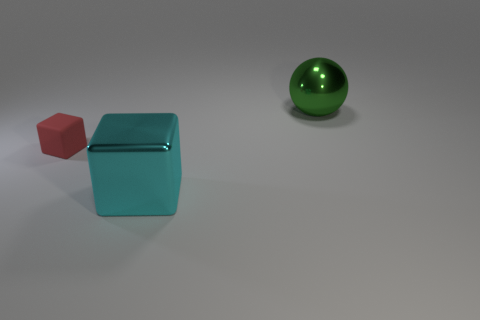Add 3 big spheres. How many objects exist? 6 Subtract 2 cubes. How many cubes are left? 0 Subtract all tiny balls. Subtract all large metallic objects. How many objects are left? 1 Add 2 small matte blocks. How many small matte blocks are left? 3 Add 3 big metal things. How many big metal things exist? 5 Subtract 1 cyan blocks. How many objects are left? 2 Subtract all balls. How many objects are left? 2 Subtract all gray balls. Subtract all gray cubes. How many balls are left? 1 